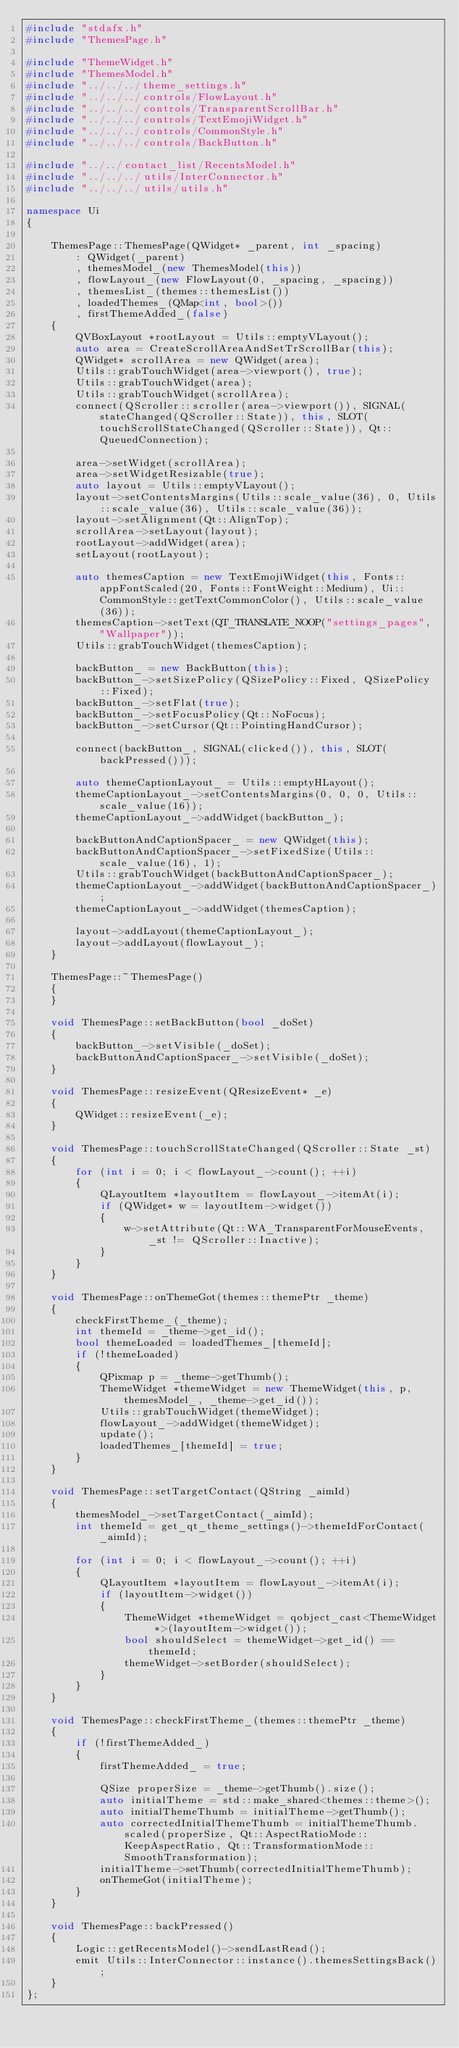Convert code to text. <code><loc_0><loc_0><loc_500><loc_500><_C++_>#include "stdafx.h"
#include "ThemesPage.h"

#include "ThemeWidget.h"
#include "ThemesModel.h"
#include "../../../theme_settings.h"
#include "../../../controls/FlowLayout.h"
#include "../../../controls/TransparentScrollBar.h"
#include "../../../controls/TextEmojiWidget.h"
#include "../../../controls/CommonStyle.h"
#include "../../../controls/BackButton.h"

#include "../../contact_list/RecentsModel.h"
#include "../../../utils/InterConnector.h"
#include "../../../utils/utils.h"

namespace Ui
{

    ThemesPage::ThemesPage(QWidget* _parent, int _spacing)
        : QWidget(_parent)
        , themesModel_(new ThemesModel(this))
        , flowLayout_(new FlowLayout(0, _spacing, _spacing))
        , themesList_(themes::themesList())
        , loadedThemes_(QMap<int, bool>())
        , firstThemeAdded_(false)
    {
        QVBoxLayout *rootLayout = Utils::emptyVLayout();
        auto area = CreateScrollAreaAndSetTrScrollBar(this);
        QWidget* scrollArea = new QWidget(area);
        Utils::grabTouchWidget(area->viewport(), true);
        Utils::grabTouchWidget(area);
        Utils::grabTouchWidget(scrollArea);
        connect(QScroller::scroller(area->viewport()), SIGNAL(stateChanged(QScroller::State)), this, SLOT(touchScrollStateChanged(QScroller::State)), Qt::QueuedConnection);

        area->setWidget(scrollArea);
        area->setWidgetResizable(true);
        auto layout = Utils::emptyVLayout();
        layout->setContentsMargins(Utils::scale_value(36), 0, Utils::scale_value(36), Utils::scale_value(36));
        layout->setAlignment(Qt::AlignTop);
        scrollArea->setLayout(layout);
        rootLayout->addWidget(area);
        setLayout(rootLayout);

        auto themesCaption = new TextEmojiWidget(this, Fonts::appFontScaled(20, Fonts::FontWeight::Medium), Ui::CommonStyle::getTextCommonColor(), Utils::scale_value(36));
        themesCaption->setText(QT_TRANSLATE_NOOP("settings_pages", "Wallpaper"));
        Utils::grabTouchWidget(themesCaption);

        backButton_ = new BackButton(this);
        backButton_->setSizePolicy(QSizePolicy::Fixed, QSizePolicy::Fixed);
        backButton_->setFlat(true);
        backButton_->setFocusPolicy(Qt::NoFocus);
        backButton_->setCursor(Qt::PointingHandCursor);

        connect(backButton_, SIGNAL(clicked()), this, SLOT(backPressed()));

        auto themeCaptionLayout_ = Utils::emptyHLayout();
        themeCaptionLayout_->setContentsMargins(0, 0, 0, Utils::scale_value(16));
        themeCaptionLayout_->addWidget(backButton_);

        backButtonAndCaptionSpacer_ = new QWidget(this);
        backButtonAndCaptionSpacer_->setFixedSize(Utils::scale_value(16), 1);
        Utils::grabTouchWidget(backButtonAndCaptionSpacer_);
        themeCaptionLayout_->addWidget(backButtonAndCaptionSpacer_);
        themeCaptionLayout_->addWidget(themesCaption);

        layout->addLayout(themeCaptionLayout_);
        layout->addLayout(flowLayout_);
    }

    ThemesPage::~ThemesPage()
    {
    }

    void ThemesPage::setBackButton(bool _doSet)
    {
        backButton_->setVisible(_doSet);
        backButtonAndCaptionSpacer_->setVisible(_doSet);
    }

    void ThemesPage::resizeEvent(QResizeEvent* _e)
    {
        QWidget::resizeEvent(_e);
    }

    void ThemesPage::touchScrollStateChanged(QScroller::State _st)
    {
        for (int i = 0; i < flowLayout_->count(); ++i)
        {
            QLayoutItem *layoutItem = flowLayout_->itemAt(i);
            if (QWidget* w = layoutItem->widget())
            {
                w->setAttribute(Qt::WA_TransparentForMouseEvents, _st != QScroller::Inactive);
            }
        }
    }

    void ThemesPage::onThemeGot(themes::themePtr _theme)
    {
        checkFirstTheme_(_theme);
        int themeId = _theme->get_id();
        bool themeLoaded = loadedThemes_[themeId];
        if (!themeLoaded)
        {
            QPixmap p = _theme->getThumb();
            ThemeWidget *themeWidget = new ThemeWidget(this, p, themesModel_, _theme->get_id());
            Utils::grabTouchWidget(themeWidget);
            flowLayout_->addWidget(themeWidget);
            update();
            loadedThemes_[themeId] = true;
        }
    }

    void ThemesPage::setTargetContact(QString _aimId)
    {
        themesModel_->setTargetContact(_aimId);
        int themeId = get_qt_theme_settings()->themeIdForContact(_aimId);

        for (int i = 0; i < flowLayout_->count(); ++i)
        {
            QLayoutItem *layoutItem = flowLayout_->itemAt(i);
            if (layoutItem->widget())
            {
                ThemeWidget *themeWidget = qobject_cast<ThemeWidget *>(layoutItem->widget());
                bool shouldSelect = themeWidget->get_id() == themeId;
                themeWidget->setBorder(shouldSelect);
            }
        }
    }

    void ThemesPage::checkFirstTheme_(themes::themePtr _theme)
    {
        if (!firstThemeAdded_)
        {
            firstThemeAdded_ = true;

            QSize properSize = _theme->getThumb().size();
            auto initialTheme = std::make_shared<themes::theme>();
            auto initialThemeThumb = initialTheme->getThumb();
            auto correctedInitialThemeThumb = initialThemeThumb.scaled(properSize, Qt::AspectRatioMode::KeepAspectRatio, Qt::TransformationMode::SmoothTransformation);
            initialTheme->setThumb(correctedInitialThemeThumb);
            onThemeGot(initialTheme);
        }
    }

    void ThemesPage::backPressed()
    {
        Logic::getRecentsModel()->sendLastRead();
        emit Utils::InterConnector::instance().themesSettingsBack();
    }
};
</code> 